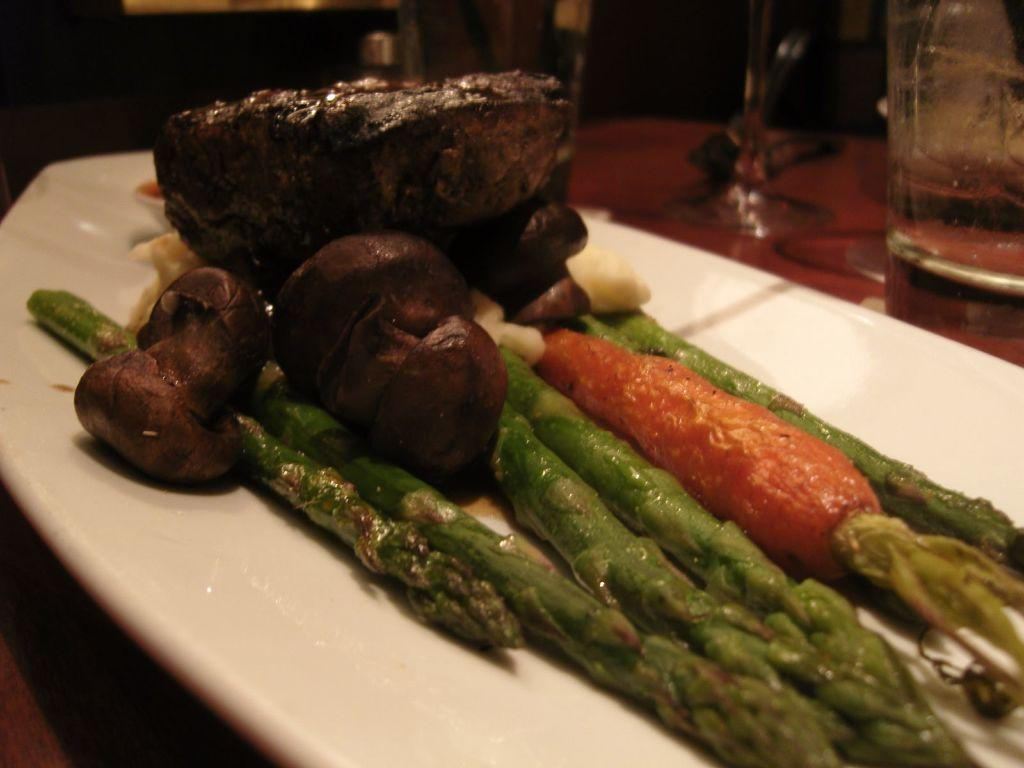What type of vegetable can be seen on the plate in the image? There is a cooked carrot on a plate in the image. What else is on the plate besides the cooked carrot? There are other vegetables on the plate. What color is the plate in the image? The plate is white. What can be seen on the right side of the image? There is a glass on the right side of the image. Can you see any farm animals near the plate in the image? There are no farm animals present in the image. What type of badge is visible on the plate in the image? There is no badge present in the image. 